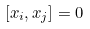Convert formula to latex. <formula><loc_0><loc_0><loc_500><loc_500>[ x _ { i } , x _ { j } ] = 0</formula> 